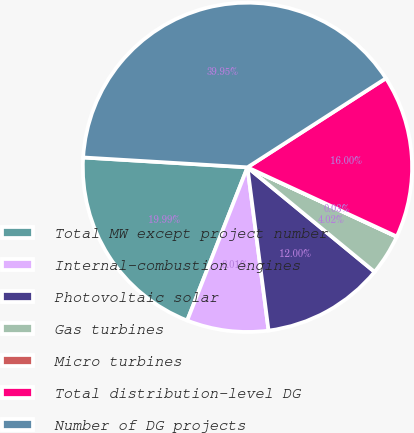Convert chart to OTSL. <chart><loc_0><loc_0><loc_500><loc_500><pie_chart><fcel>Total MW except project number<fcel>Internal-combustion engines<fcel>Photovoltaic solar<fcel>Gas turbines<fcel>Micro turbines<fcel>Total distribution-level DG<fcel>Number of DG projects<nl><fcel>19.99%<fcel>8.01%<fcel>12.0%<fcel>4.02%<fcel>0.03%<fcel>16.0%<fcel>39.95%<nl></chart> 